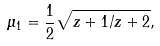Convert formula to latex. <formula><loc_0><loc_0><loc_500><loc_500>\mu _ { 1 } = \frac { 1 } { 2 } \sqrt { z + 1 / z + 2 } ,</formula> 